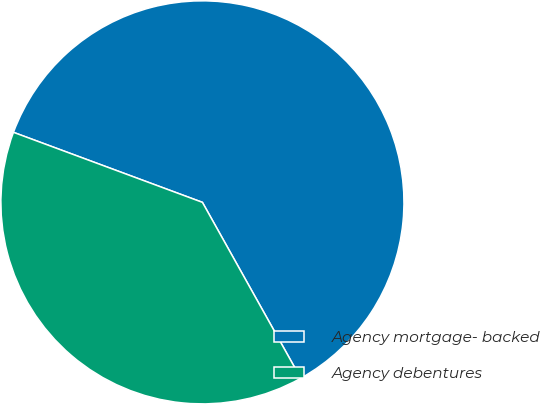Convert chart. <chart><loc_0><loc_0><loc_500><loc_500><pie_chart><fcel>Agency mortgage- backed<fcel>Agency debentures<nl><fcel>61.24%<fcel>38.76%<nl></chart> 